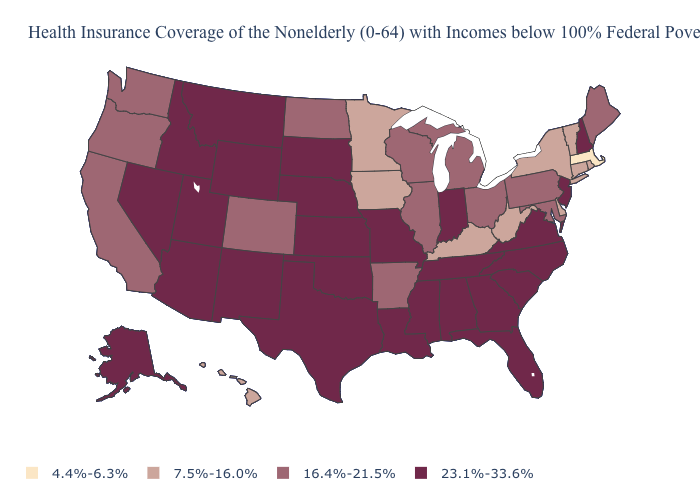Does Colorado have the same value as Washington?
Short answer required. Yes. Which states have the lowest value in the USA?
Give a very brief answer. Massachusetts. Which states have the lowest value in the MidWest?
Quick response, please. Iowa, Minnesota. What is the value of Kentucky?
Be succinct. 7.5%-16.0%. Which states have the lowest value in the West?
Quick response, please. Hawaii. Name the states that have a value in the range 23.1%-33.6%?
Concise answer only. Alabama, Alaska, Arizona, Florida, Georgia, Idaho, Indiana, Kansas, Louisiana, Mississippi, Missouri, Montana, Nebraska, Nevada, New Hampshire, New Jersey, New Mexico, North Carolina, Oklahoma, South Carolina, South Dakota, Tennessee, Texas, Utah, Virginia, Wyoming. What is the highest value in states that border Connecticut?
Be succinct. 7.5%-16.0%. What is the value of Wisconsin?
Keep it brief. 16.4%-21.5%. Among the states that border Oregon , which have the lowest value?
Be succinct. California, Washington. How many symbols are there in the legend?
Answer briefly. 4. Name the states that have a value in the range 4.4%-6.3%?
Write a very short answer. Massachusetts. How many symbols are there in the legend?
Answer briefly. 4. Does Wisconsin have the highest value in the MidWest?
Give a very brief answer. No. Name the states that have a value in the range 16.4%-21.5%?
Quick response, please. Arkansas, California, Colorado, Illinois, Maine, Maryland, Michigan, North Dakota, Ohio, Oregon, Pennsylvania, Washington, Wisconsin. Name the states that have a value in the range 4.4%-6.3%?
Write a very short answer. Massachusetts. 